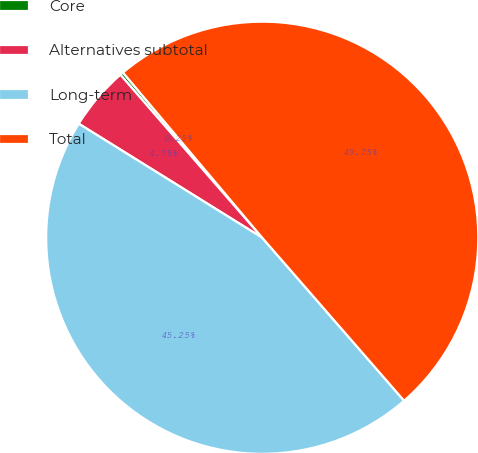Convert chart to OTSL. <chart><loc_0><loc_0><loc_500><loc_500><pie_chart><fcel>Core<fcel>Alternatives subtotal<fcel>Long-term<fcel>Total<nl><fcel>0.25%<fcel>4.75%<fcel>45.25%<fcel>49.75%<nl></chart> 